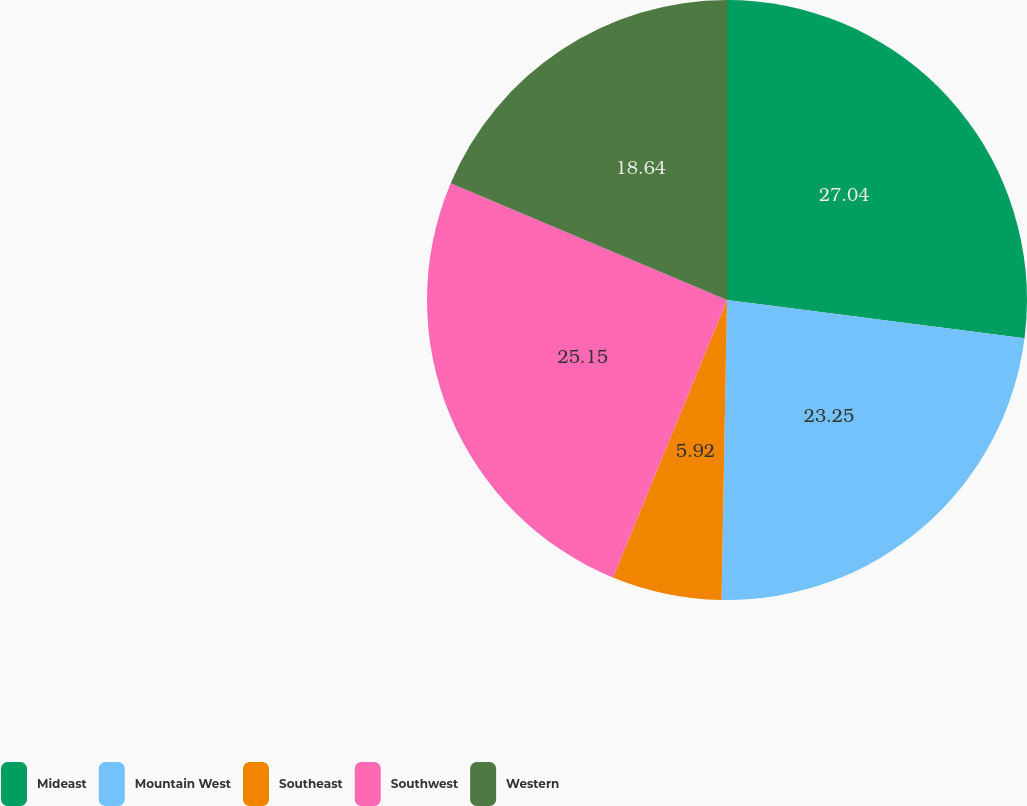Convert chart to OTSL. <chart><loc_0><loc_0><loc_500><loc_500><pie_chart><fcel>Mideast<fcel>Mountain West<fcel>Southeast<fcel>Southwest<fcel>Western<nl><fcel>27.04%<fcel>23.25%<fcel>5.92%<fcel>25.15%<fcel>18.64%<nl></chart> 